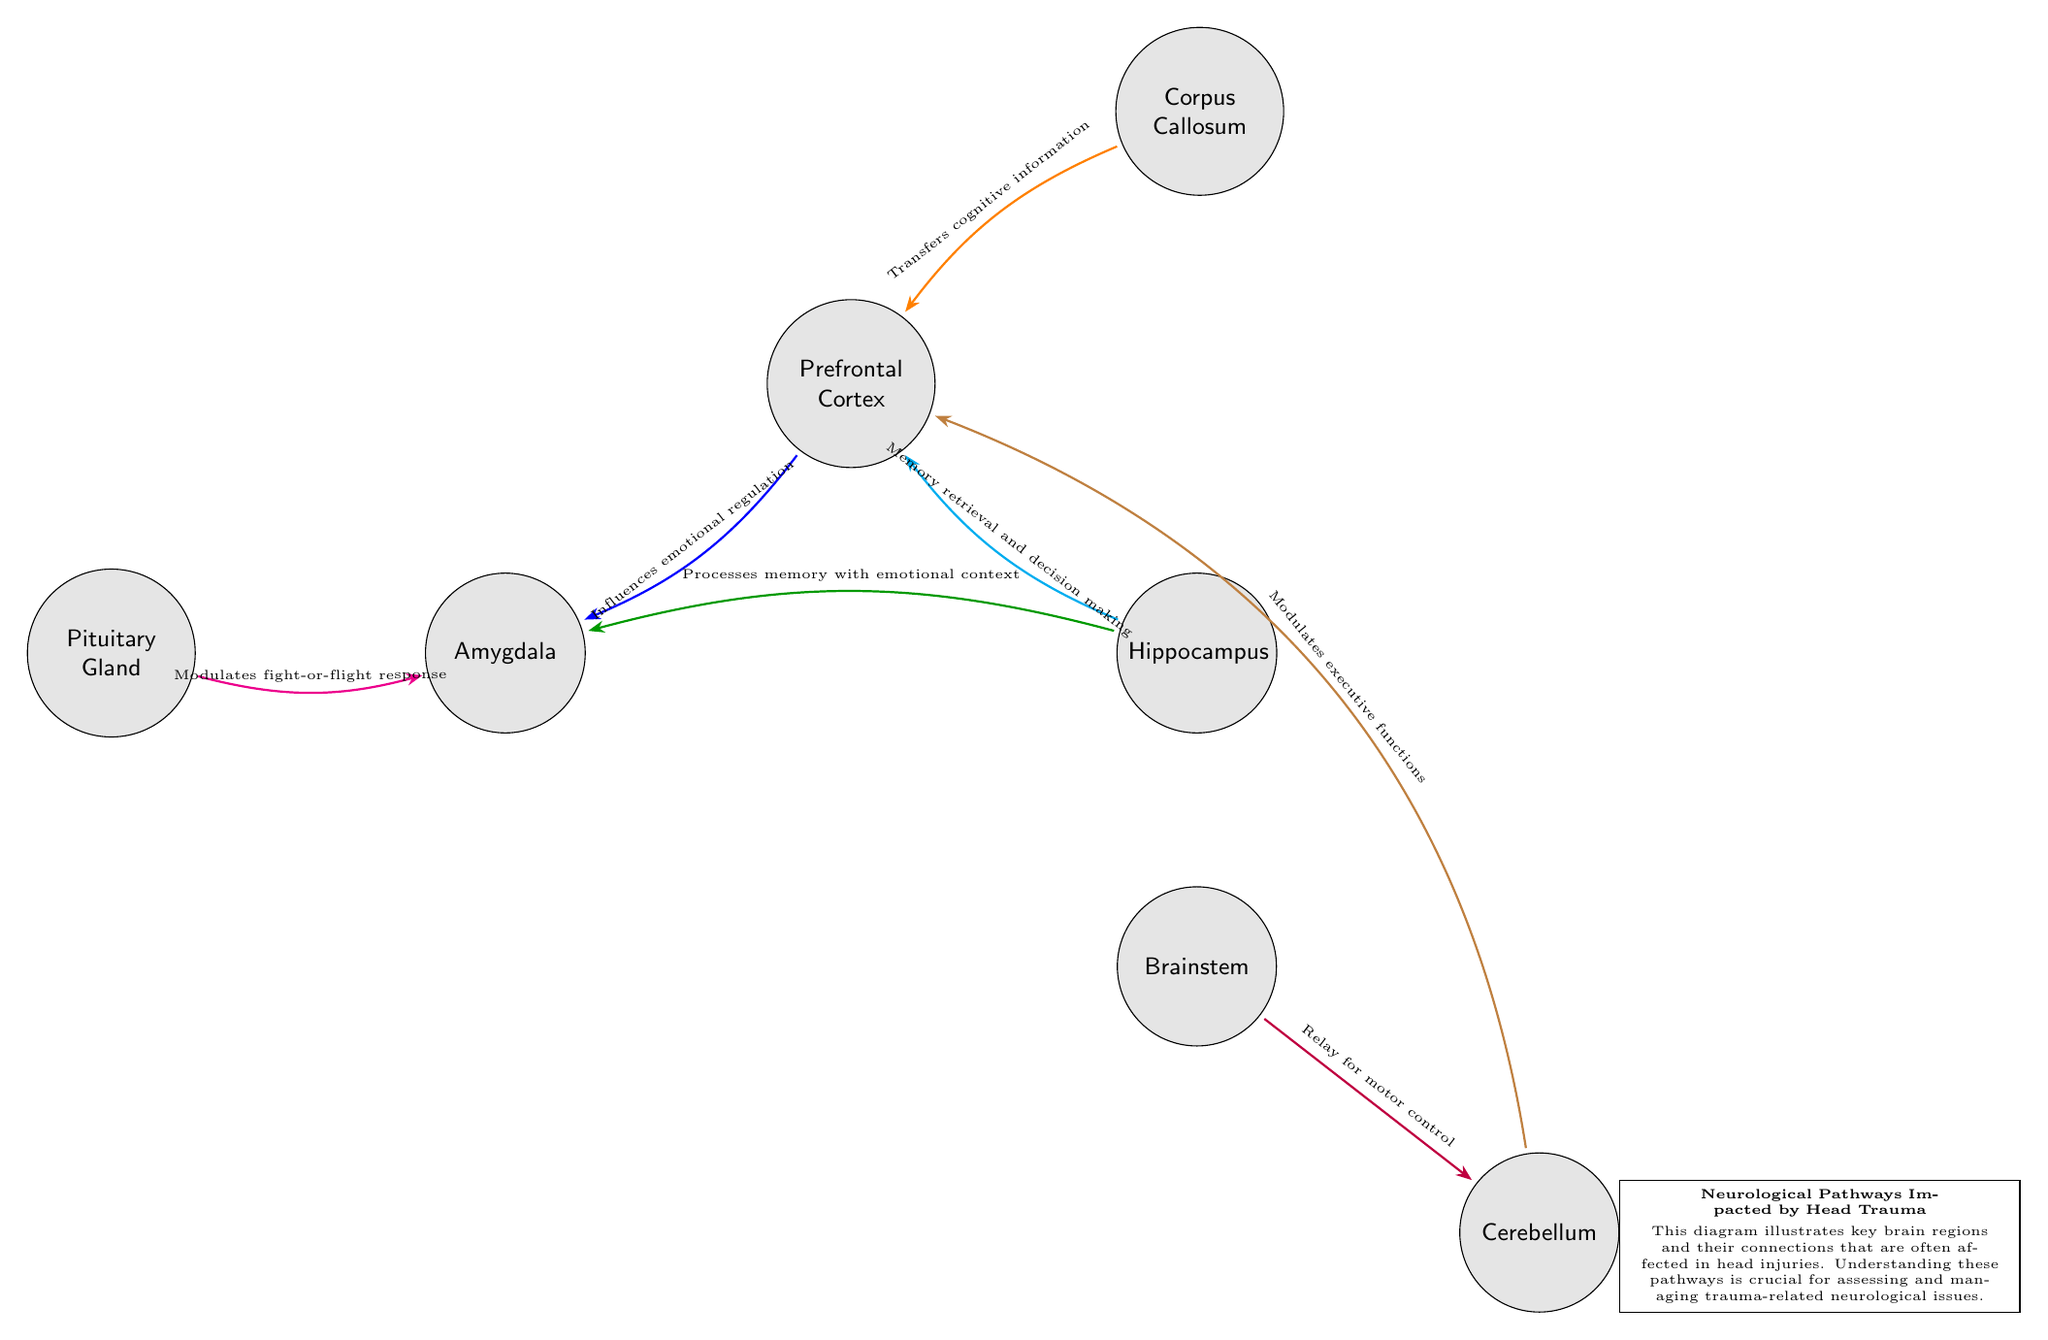What are the main brain regions shown in the diagram? The diagram includes seven brain regions: Prefrontal Cortex, Hippocampus, Amygdala, Corpus Callosum, Brainstem, Cerebellum, and Pituitary Gland.
Answer: Prefrontal Cortex, Hippocampus, Amygdala, Corpus Callosum, Brainstem, Cerebellum, Pituitary Gland How many connections are there between the brain regions? The diagram shows six connections between the various brain regions.
Answer: 6 What is the function of the connection between the Prefrontal Cortex and Amygdala? The connection between the Prefrontal Cortex and Amygdala indicates that the Prefrontal Cortex influences emotional regulation, which is specifically labeled above the connection line in the diagram.
Answer: Influences emotional regulation Which brain region processes memory with emotional context? The Hippo-campus is the region that processes memory with emotional context, as identified by the labeled connection leading to the Amygdala.
Answer: Hippocampus What role does the Brainstem play in relation to the Cerebellum? The Brainstem acts as a relay for motor control to the Cerebellum, according to the connection shown in the diagram.
Answer: Relay for motor control Explain how the Hippocampus is related to decision-making? The Hippocampus connects to the Prefrontal Cortex with a function labeled as memory retrieval and decision making, implying its involvement in these cognitive processes.
Answer: Memory retrieval and decision making Which brain region modulates the fight-or-flight response? The Pituitary Gland modulates the fight-or-flight response, as denoted by the connection to the Amygdala in the diagram.
Answer: Pituitary Gland What indicates the relationship between the Corpus Callosum and Prefrontal Cortex? The connection shows that the Corpus Callosum transfers cognitive information to the Prefrontal Cortex, demonstrating a critical communication link between these areas.
Answer: Transfers cognitive information 